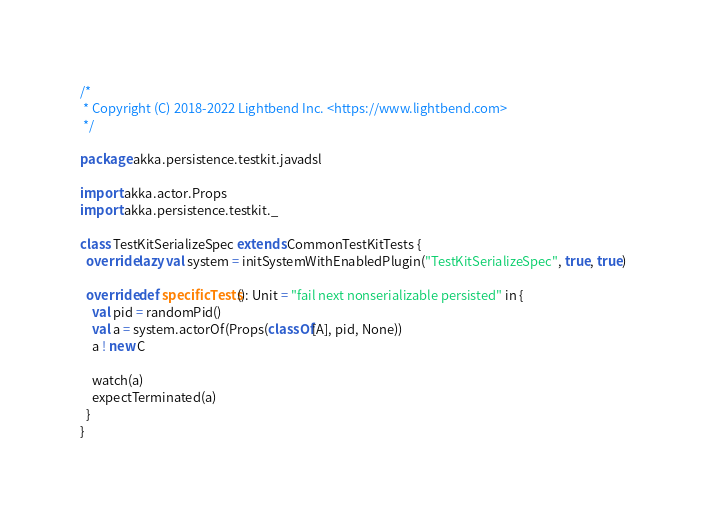<code> <loc_0><loc_0><loc_500><loc_500><_Scala_>/*
 * Copyright (C) 2018-2022 Lightbend Inc. <https://www.lightbend.com>
 */

package akka.persistence.testkit.javadsl

import akka.actor.Props
import akka.persistence.testkit._

class TestKitSerializeSpec extends CommonTestKitTests {
  override lazy val system = initSystemWithEnabledPlugin("TestKitSerializeSpec", true, true)

  override def specificTests(): Unit = "fail next nonserializable persisted" in {
    val pid = randomPid()
    val a = system.actorOf(Props(classOf[A], pid, None))
    a ! new C

    watch(a)
    expectTerminated(a)
  }
}
</code> 